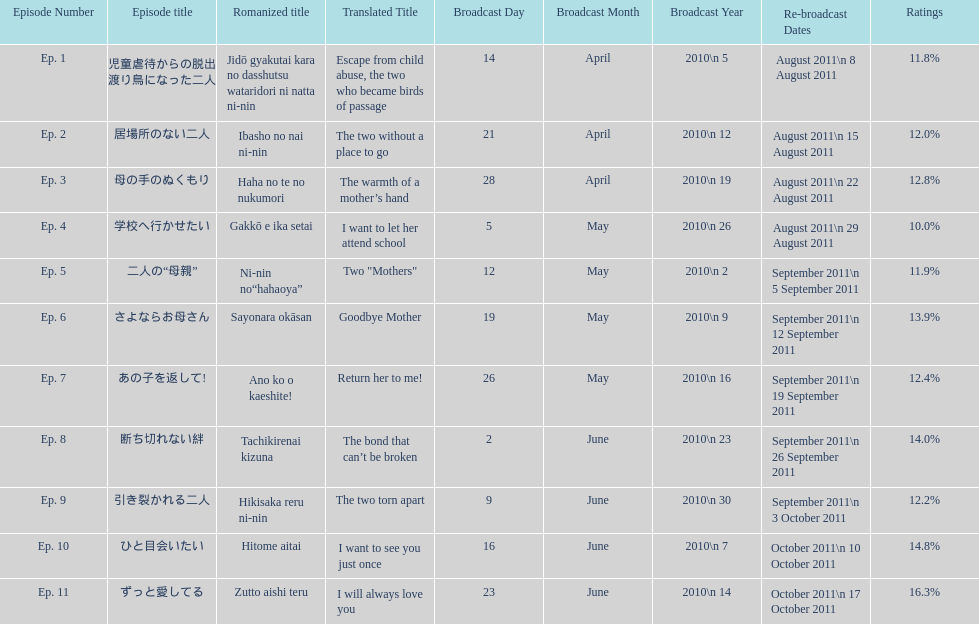How many episodes were broadcast in april 2010 in japan? 3. 